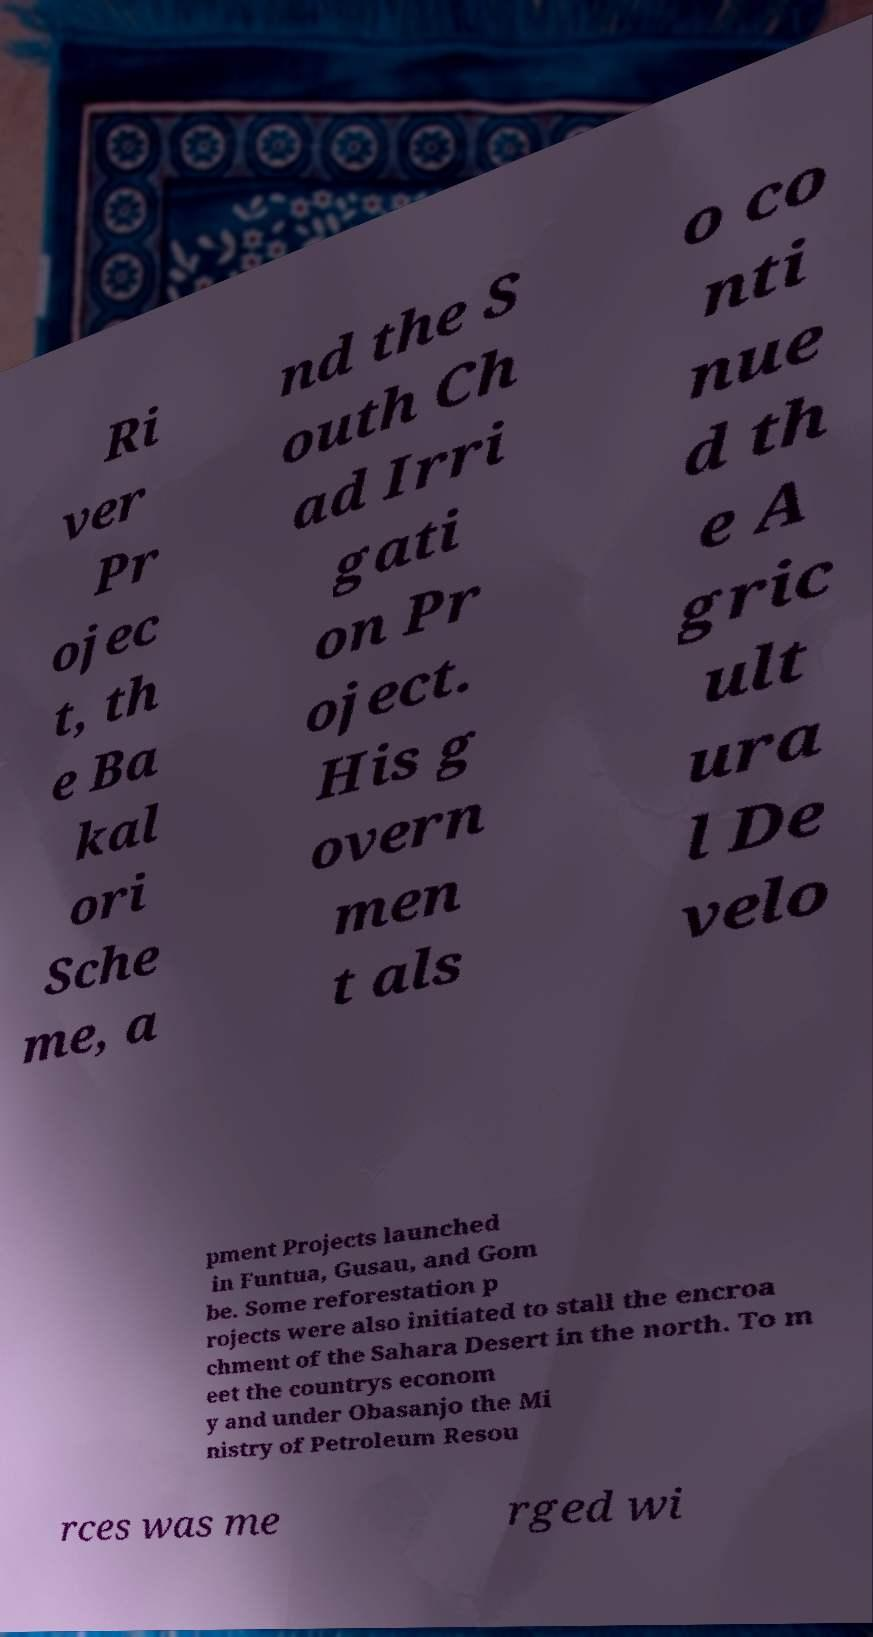There's text embedded in this image that I need extracted. Can you transcribe it verbatim? Ri ver Pr ojec t, th e Ba kal ori Sche me, a nd the S outh Ch ad Irri gati on Pr oject. His g overn men t als o co nti nue d th e A gric ult ura l De velo pment Projects launched in Funtua, Gusau, and Gom be. Some reforestation p rojects were also initiated to stall the encroa chment of the Sahara Desert in the north. To m eet the countrys econom y and under Obasanjo the Mi nistry of Petroleum Resou rces was me rged wi 